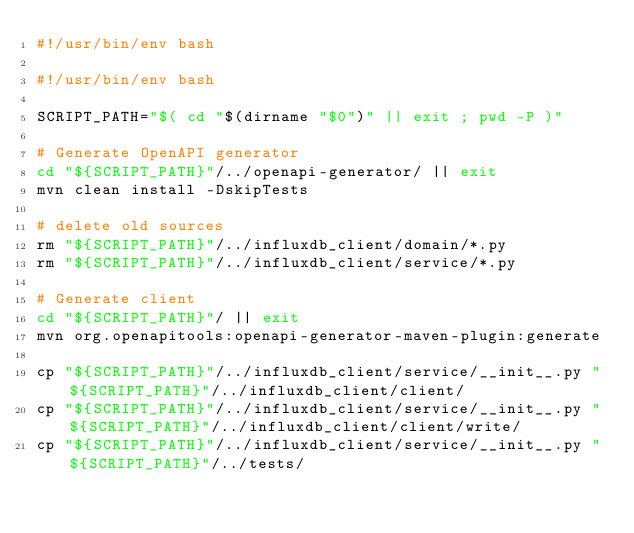Convert code to text. <code><loc_0><loc_0><loc_500><loc_500><_Bash_>#!/usr/bin/env bash

#!/usr/bin/env bash

SCRIPT_PATH="$( cd "$(dirname "$0")" || exit ; pwd -P )"

# Generate OpenAPI generator
cd "${SCRIPT_PATH}"/../openapi-generator/ || exit
mvn clean install -DskipTests

# delete old sources
rm "${SCRIPT_PATH}"/../influxdb_client/domain/*.py
rm "${SCRIPT_PATH}"/../influxdb_client/service/*.py

# Generate client
cd "${SCRIPT_PATH}"/ || exit
mvn org.openapitools:openapi-generator-maven-plugin:generate

cp "${SCRIPT_PATH}"/../influxdb_client/service/__init__.py "${SCRIPT_PATH}"/../influxdb_client/client/
cp "${SCRIPT_PATH}"/../influxdb_client/service/__init__.py "${SCRIPT_PATH}"/../influxdb_client/client/write/
cp "${SCRIPT_PATH}"/../influxdb_client/service/__init__.py "${SCRIPT_PATH}"/../tests/</code> 